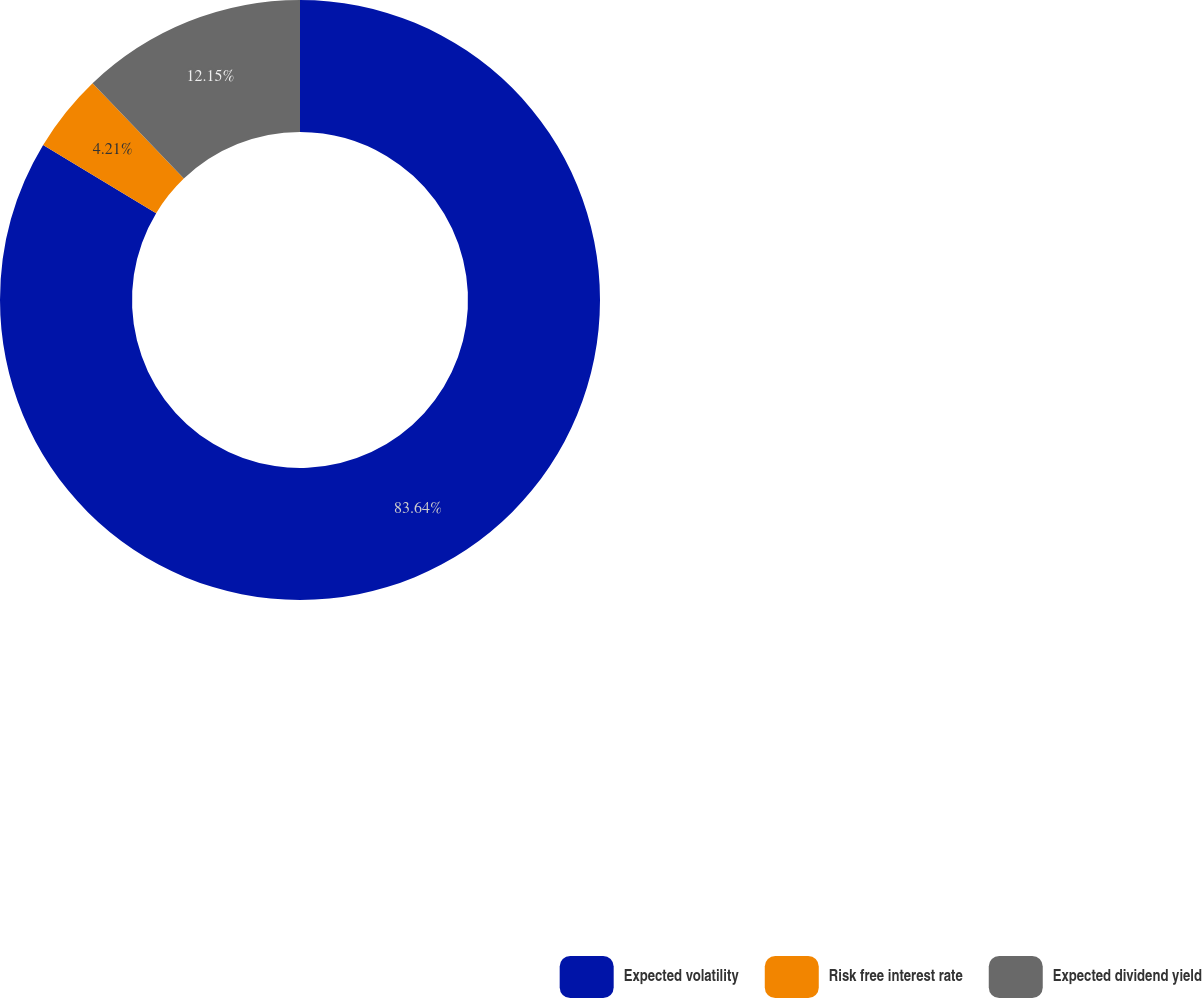<chart> <loc_0><loc_0><loc_500><loc_500><pie_chart><fcel>Expected volatility<fcel>Risk free interest rate<fcel>Expected dividend yield<nl><fcel>83.64%<fcel>4.21%<fcel>12.15%<nl></chart> 